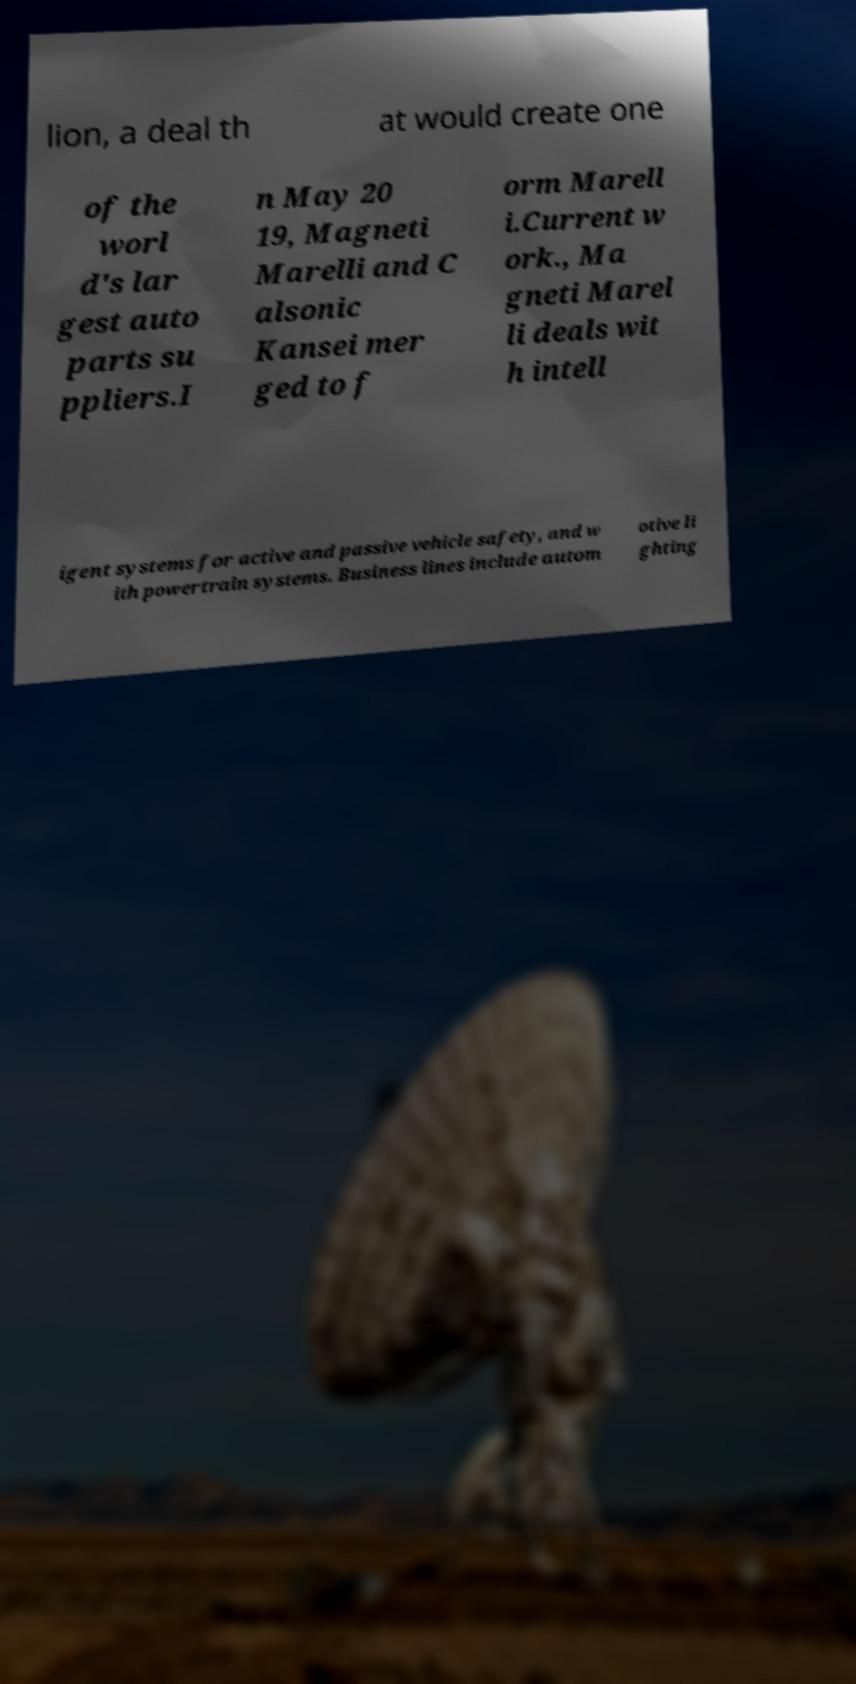I need the written content from this picture converted into text. Can you do that? lion, a deal th at would create one of the worl d's lar gest auto parts su ppliers.I n May 20 19, Magneti Marelli and C alsonic Kansei mer ged to f orm Marell i.Current w ork., Ma gneti Marel li deals wit h intell igent systems for active and passive vehicle safety, and w ith powertrain systems. Business lines include autom otive li ghting 